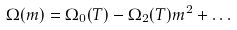Convert formula to latex. <formula><loc_0><loc_0><loc_500><loc_500>\Omega ( m ) = \Omega _ { 0 } ( T ) - \Omega _ { 2 } ( T ) m ^ { 2 } + \dots</formula> 